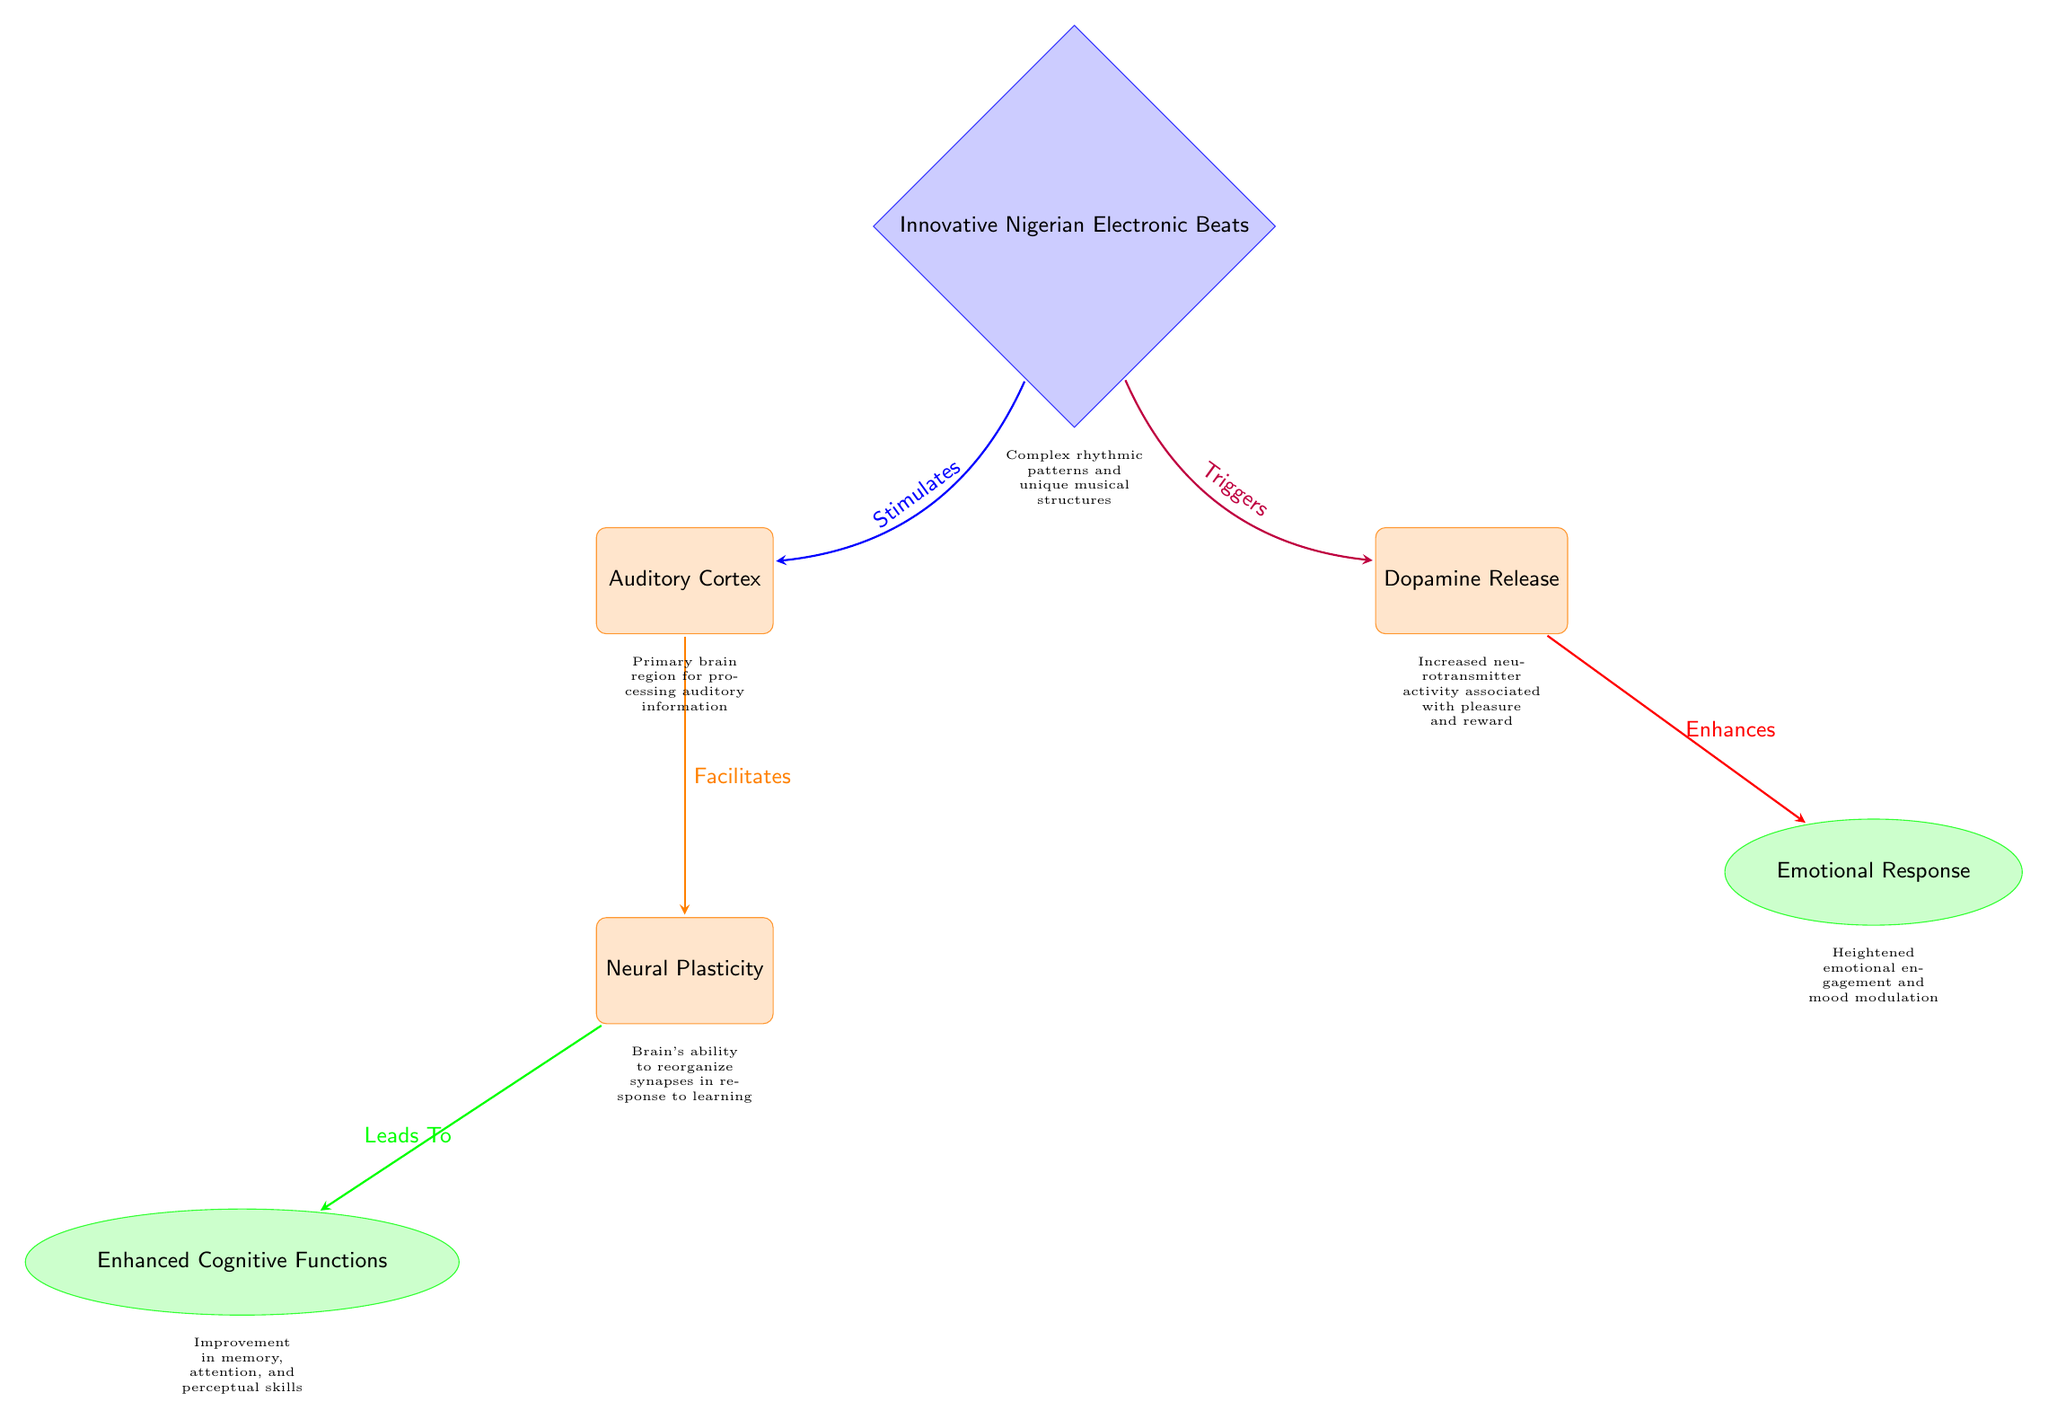What is the stimulus in the diagram? The stimulus is represented by the top diamond node labeled "Innovative Nigerian Electronic Beats," indicating it is the initiating factor in the auditory processing changes depicted.
Answer: Innovative Nigerian Electronic Beats How many processes are shown in the diagram? The diagram includes three process nodes: "Auditory Cortex," "Dopamine Release," and "Neural Plasticity." Counting these nodes gives a total of three processes.
Answer: 3 What effect results from "Neural Plasticity"? The effect linked to "Neural Plasticity" is represented by the node labeled "Enhanced Cognitive Functions," which indicates the positive outcomes of neural adaptations.
Answer: Enhanced Cognitive Functions Which node is responsible for emotional engagement? The node for emotional engagement is "Emotional Response," which is connected to the "Dopamine Release" process reflecting the link between dopamine activity and emotional effects.
Answer: Emotional Response What relationship exists between "Innovative Nigerian Electronic Beats" and "Auditory Cortex"? The relationship illustrated here is that "Innovative Nigerian Electronic Beats" stimulates the "Auditory Cortex," which is shown by the directed arrow indicating influence.
Answer: Stimulates What leads to enhanced emotional response according to the diagram? An enhanced emotional response is shown to result from the "Dopamine Release," which is a process influenced by the stimulus and connects to emotional effects.
Answer: Dopamine Release How does "Auditory Cortex" influence "Neural Plasticity"? The "Auditory Cortex" facilitates "Neural Plasticity" shown by the arrow indicating that auditory processing aids in the brain's ability to adapt and reorganize.
Answer: Facilitates How is dopamine activity characterized in the diagram? Dopamine activity is characterized by the process node labeled "Dopamine Release," which implies increased neurotransmitter activity linked to pleasure and reward mechanisms.
Answer: Increased neurotransmitter activity What brain function is associated with "Enhanced Cognitive Functions"? "Enhanced Cognitive Functions" are broadly associated with improvements in memory, attention, and perceptual skills, indicating a range of cognitive enhancements from auditory exposure.
Answer: Memory, attention, and perceptual skills 